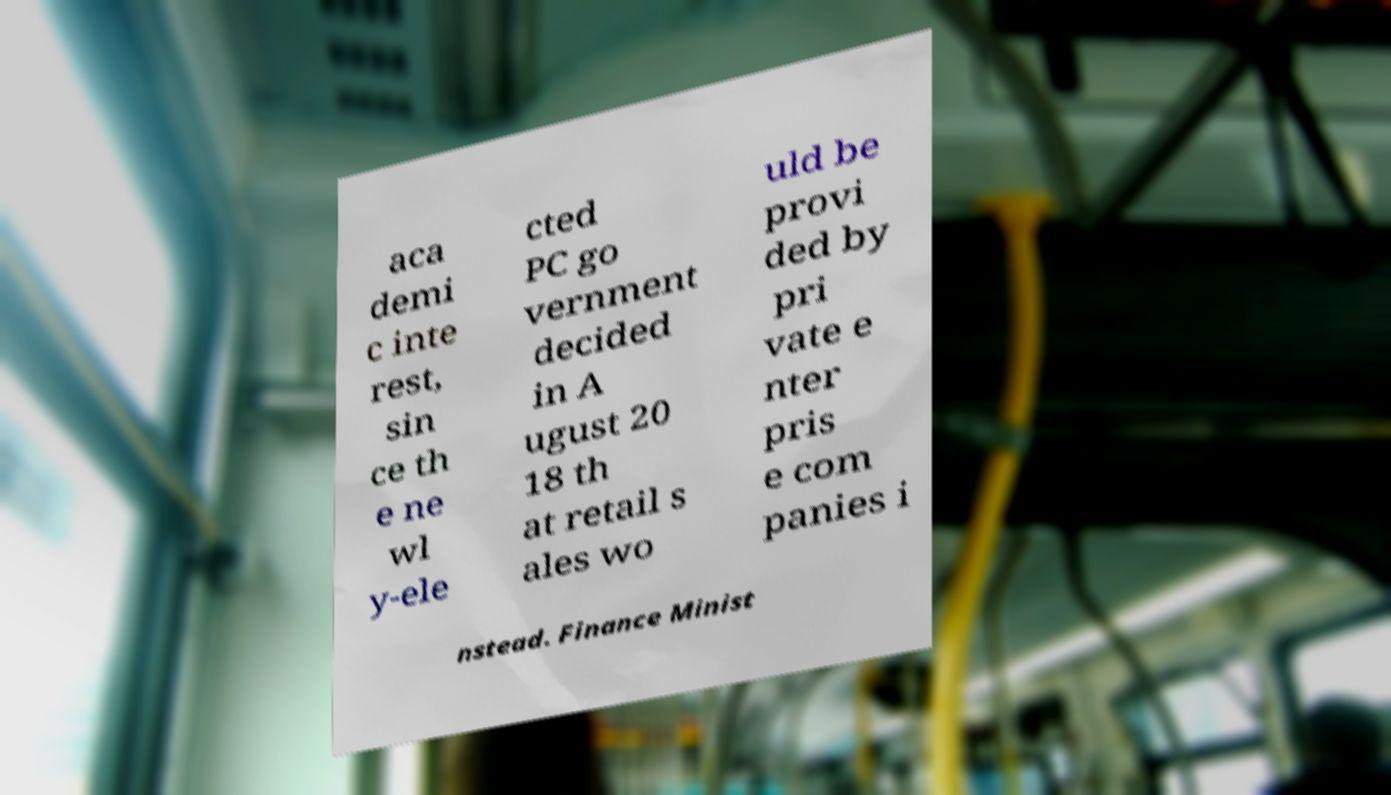For documentation purposes, I need the text within this image transcribed. Could you provide that? aca demi c inte rest, sin ce th e ne wl y-ele cted PC go vernment decided in A ugust 20 18 th at retail s ales wo uld be provi ded by pri vate e nter pris e com panies i nstead. Finance Minist 